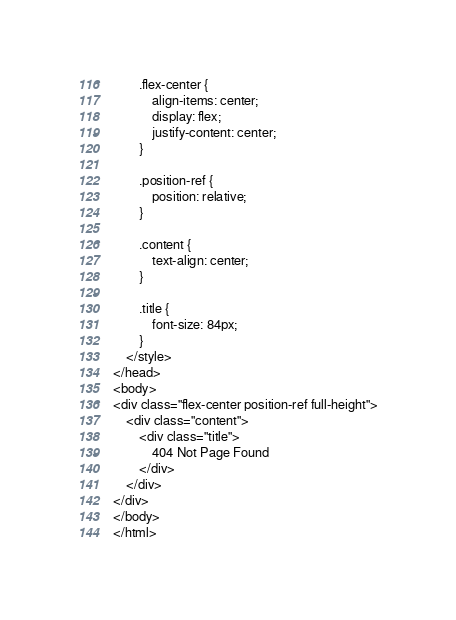Convert code to text. <code><loc_0><loc_0><loc_500><loc_500><_PHP_>        .flex-center {
            align-items: center;
            display: flex;
            justify-content: center;
        }

        .position-ref {
            position: relative;
        }

        .content {
            text-align: center;
        }

        .title {
            font-size: 84px;
        }
    </style>
</head>
<body>
<div class="flex-center position-ref full-height">
    <div class="content">
        <div class="title">
            404 Not Page Found
        </div>
    </div>
</div>
</body>
</html>
</code> 